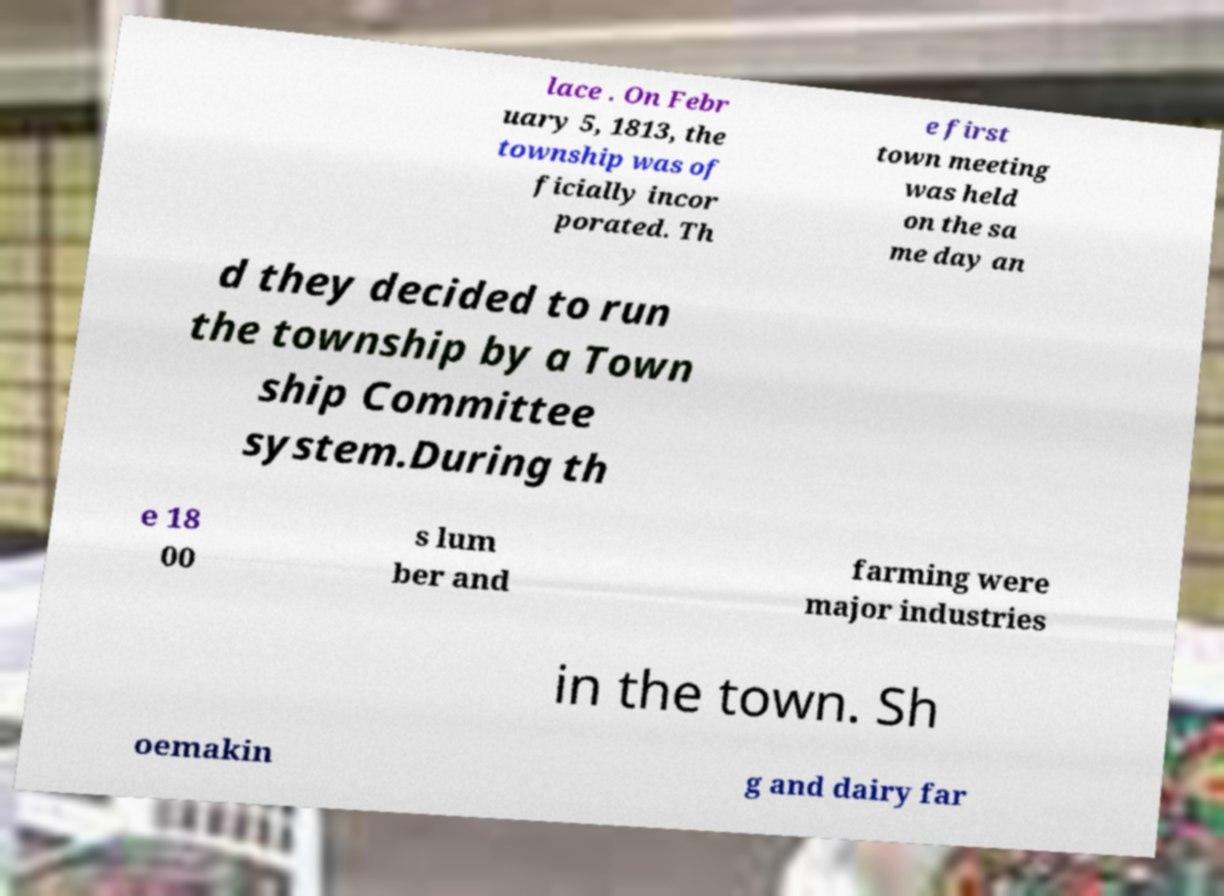Could you extract and type out the text from this image? lace . On Febr uary 5, 1813, the township was of ficially incor porated. Th e first town meeting was held on the sa me day an d they decided to run the township by a Town ship Committee system.During th e 18 00 s lum ber and farming were major industries in the town. Sh oemakin g and dairy far 